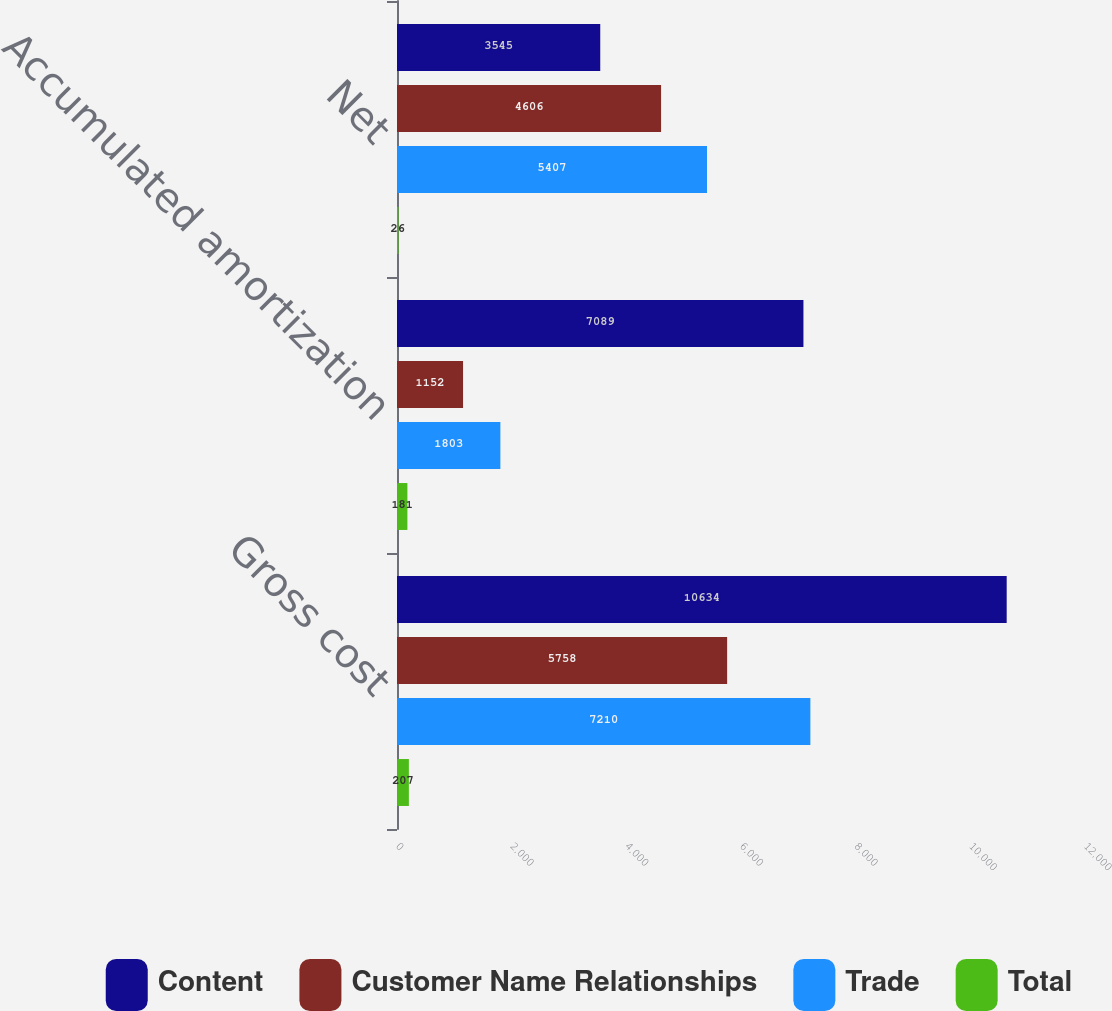<chart> <loc_0><loc_0><loc_500><loc_500><stacked_bar_chart><ecel><fcel>Gross cost<fcel>Accumulated amortization<fcel>Net<nl><fcel>Content<fcel>10634<fcel>7089<fcel>3545<nl><fcel>Customer Name Relationships<fcel>5758<fcel>1152<fcel>4606<nl><fcel>Trade<fcel>7210<fcel>1803<fcel>5407<nl><fcel>Total<fcel>207<fcel>181<fcel>26<nl></chart> 